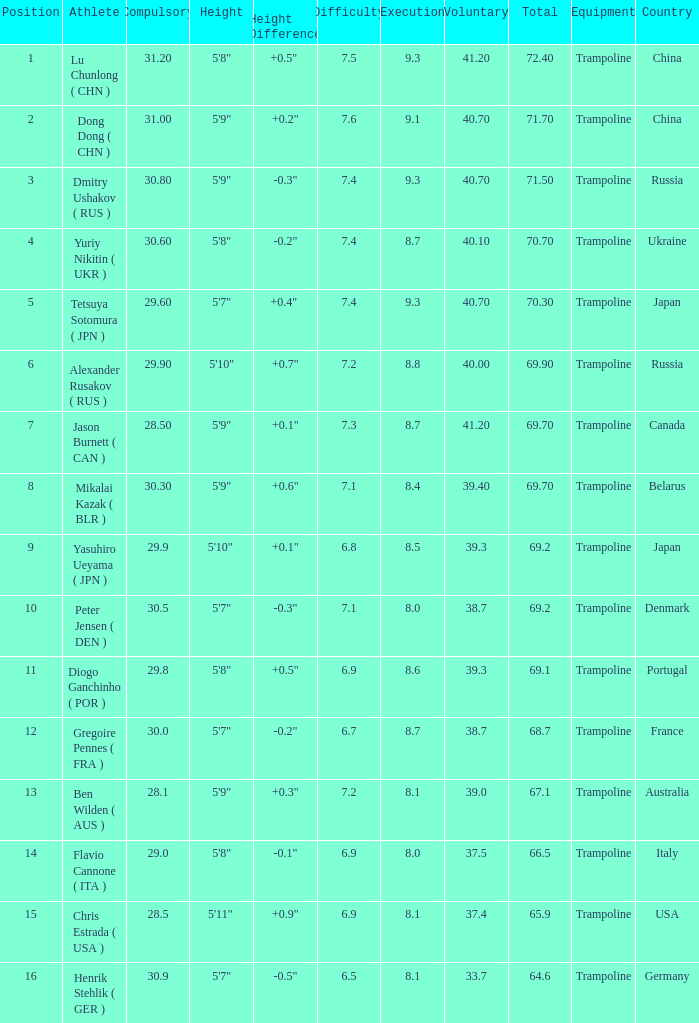What's the total compulsory when the total is more than 69.2 and the voluntary is 38.7? 0.0. 